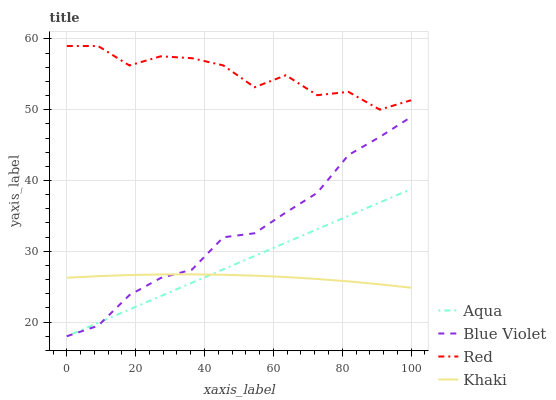Does Khaki have the minimum area under the curve?
Answer yes or no. Yes. Does Red have the maximum area under the curve?
Answer yes or no. Yes. Does Aqua have the minimum area under the curve?
Answer yes or no. No. Does Aqua have the maximum area under the curve?
Answer yes or no. No. Is Aqua the smoothest?
Answer yes or no. Yes. Is Red the roughest?
Answer yes or no. Yes. Is Red the smoothest?
Answer yes or no. No. Is Aqua the roughest?
Answer yes or no. No. Does Aqua have the lowest value?
Answer yes or no. Yes. Does Red have the lowest value?
Answer yes or no. No. Does Red have the highest value?
Answer yes or no. Yes. Does Aqua have the highest value?
Answer yes or no. No. Is Blue Violet less than Red?
Answer yes or no. Yes. Is Red greater than Khaki?
Answer yes or no. Yes. Does Khaki intersect Blue Violet?
Answer yes or no. Yes. Is Khaki less than Blue Violet?
Answer yes or no. No. Is Khaki greater than Blue Violet?
Answer yes or no. No. Does Blue Violet intersect Red?
Answer yes or no. No. 